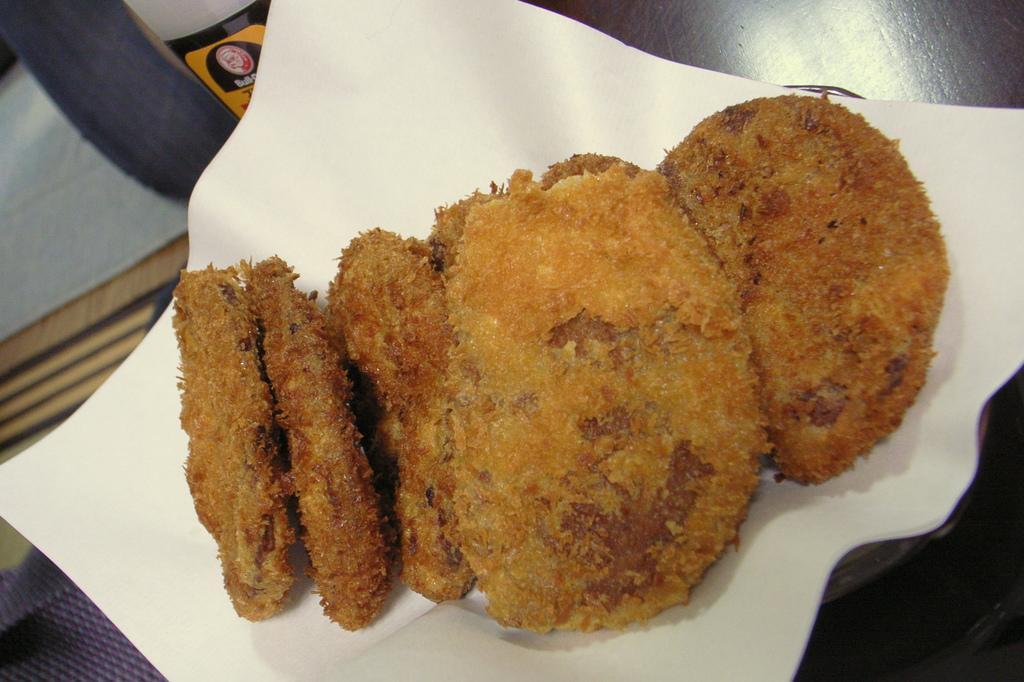In one or two sentences, can you explain what this image depicts? In this picture we can see food with paper on the platform and objects. 